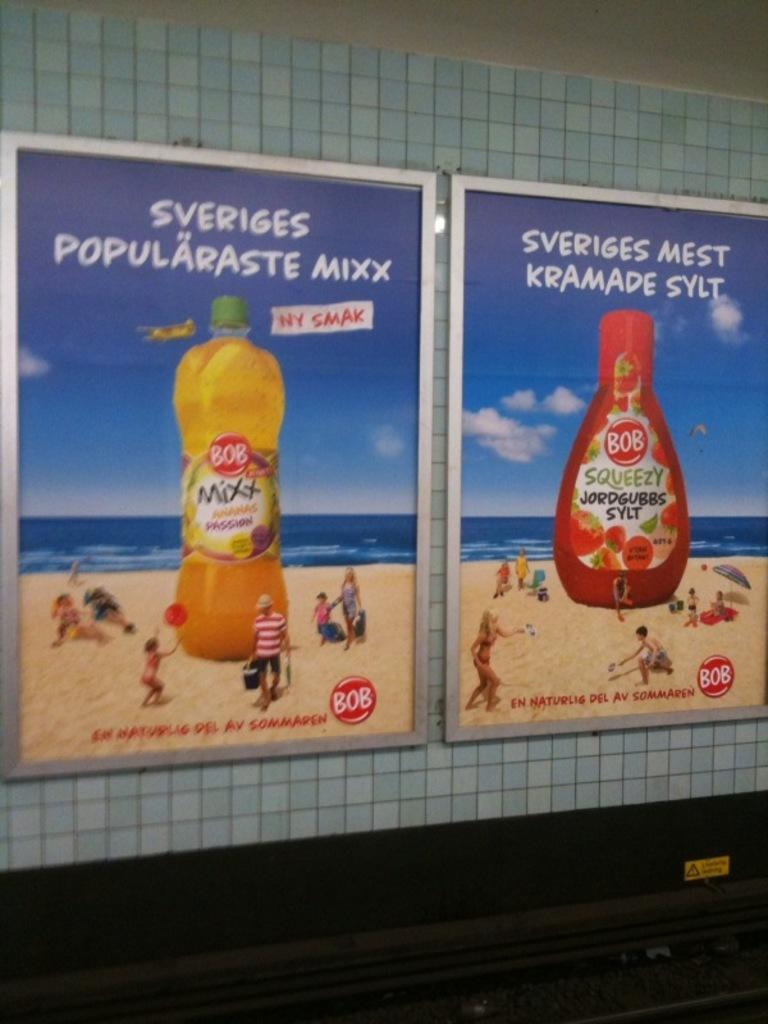<image>
Offer a succinct explanation of the picture presented. Two giant advertisement posters on a tile wall that is advertising for a company called BOB. 